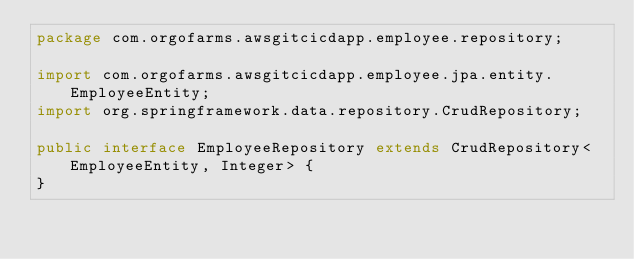<code> <loc_0><loc_0><loc_500><loc_500><_Java_>package com.orgofarms.awsgitcicdapp.employee.repository;

import com.orgofarms.awsgitcicdapp.employee.jpa.entity.EmployeeEntity;
import org.springframework.data.repository.CrudRepository;

public interface EmployeeRepository extends CrudRepository<EmployeeEntity, Integer> {
}
</code> 